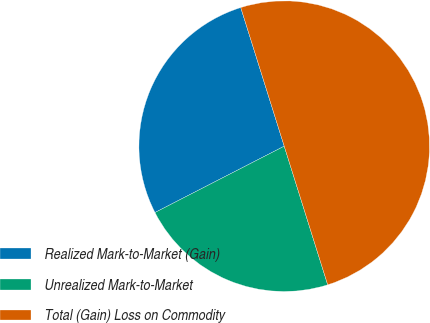Convert chart. <chart><loc_0><loc_0><loc_500><loc_500><pie_chart><fcel>Realized Mark-to-Market (Gain)<fcel>Unrealized Mark-to-Market<fcel>Total (Gain) Loss on Commodity<nl><fcel>27.71%<fcel>22.29%<fcel>50.0%<nl></chart> 